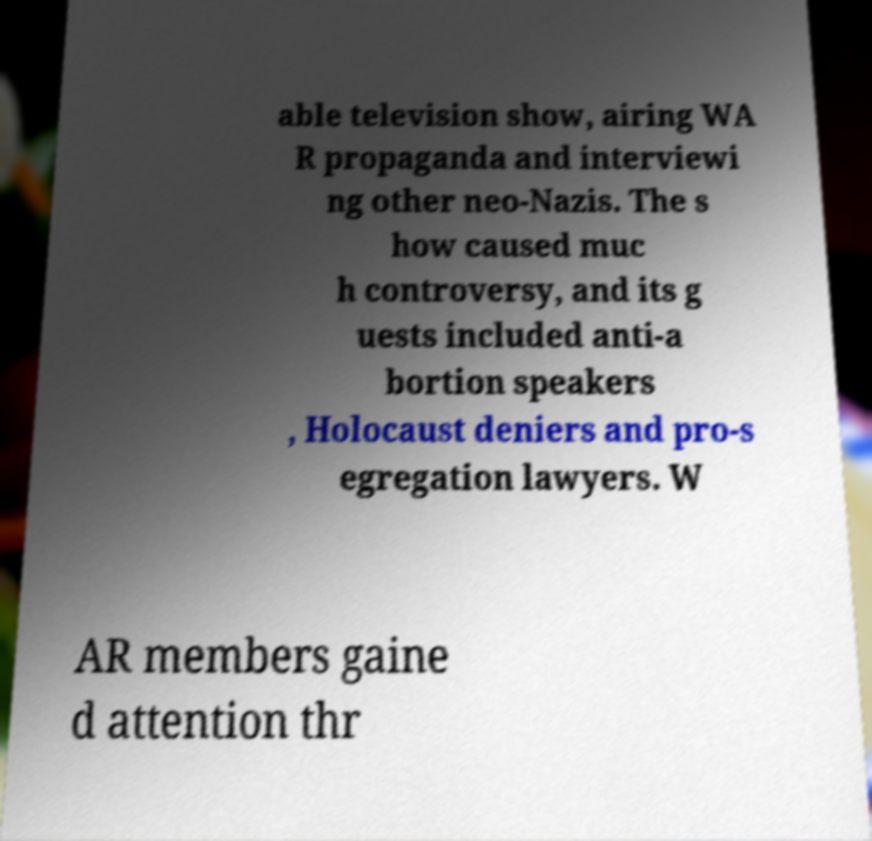There's text embedded in this image that I need extracted. Can you transcribe it verbatim? able television show, airing WA R propaganda and interviewi ng other neo-Nazis. The s how caused muc h controversy, and its g uests included anti-a bortion speakers , Holocaust deniers and pro-s egregation lawyers. W AR members gaine d attention thr 